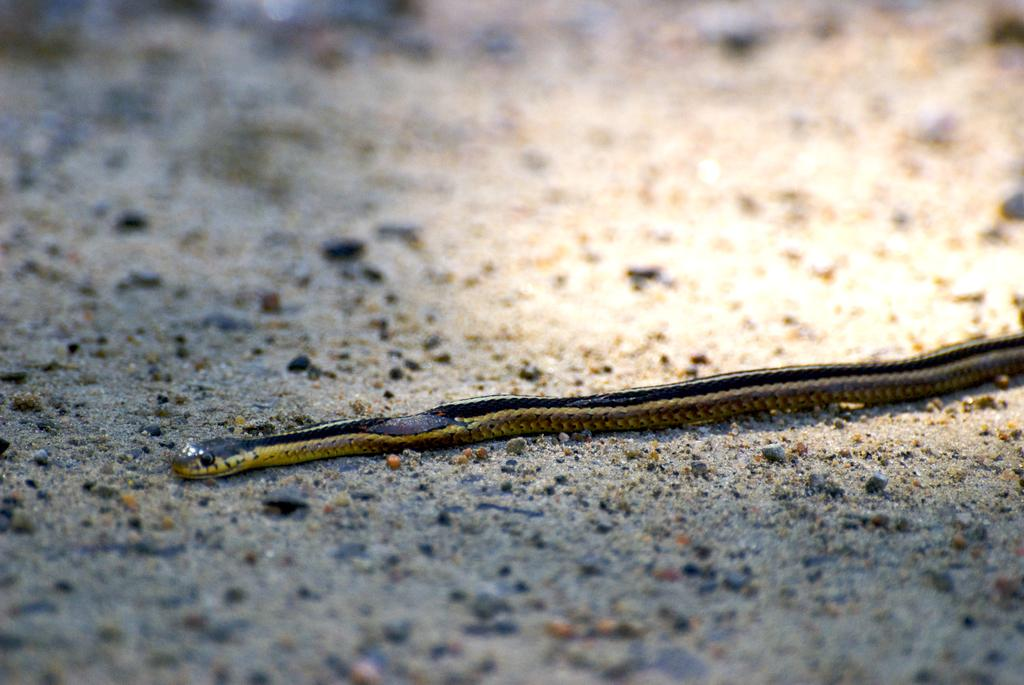What animal is present in the image? There is a snake in the picture. Where is the snake located in the image? The snake is on the ground. What colors can be seen on the snake? The snake is black and light yellow in color. What type of event is happening in the image? There is no event happening in the image; it simply shows a snake on the ground. Can you describe the face of the snake in the image? Snakes do not have faces like humans or other mammals, so there is no face to describe in the image. 